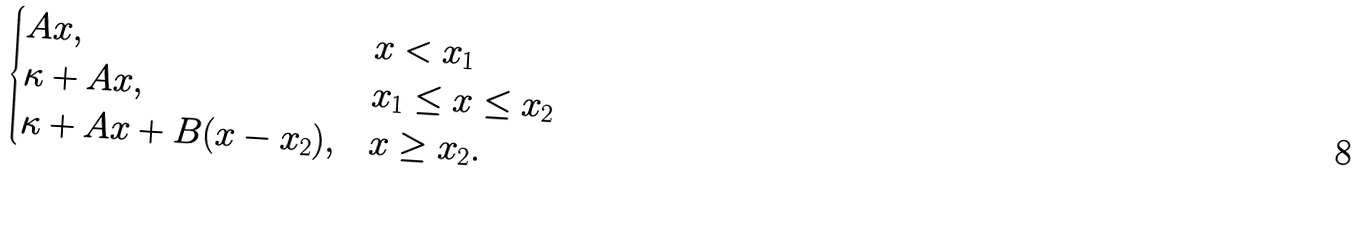<formula> <loc_0><loc_0><loc_500><loc_500>\begin{cases} A x , & x < x _ { 1 } \\ \kappa + A x , & x _ { 1 } \leq x \leq x _ { 2 } \\ \kappa + A x + B ( x - x _ { 2 } ) , & x \geq x _ { 2 } . \end{cases}</formula> 